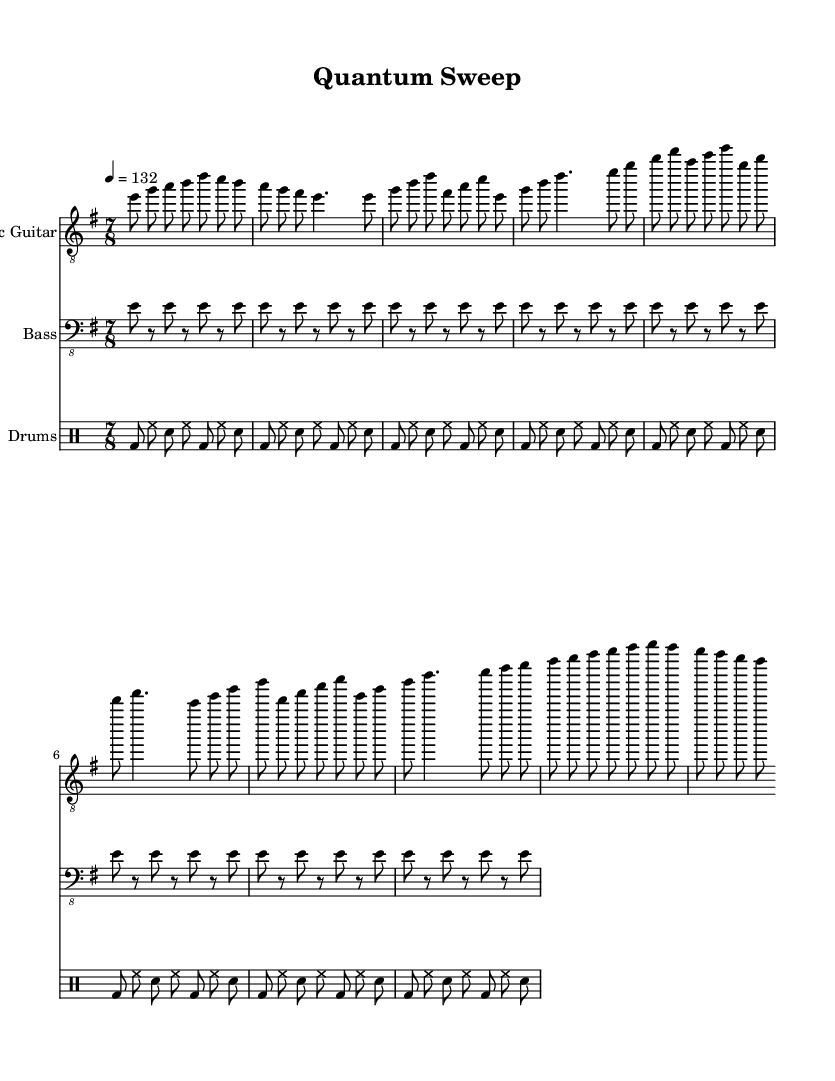What is the key signature of this music? The key signature is indicated by the presence of one sharp, which is F#. This means the piece is in E minor.
Answer: E minor What is the time signature of this music? The time signature appears at the beginning of the score, indicating that there are seven eighth notes per measure, which is expressed as 7/8.
Answer: 7/8 What is the tempo marking for this piece? The tempo marking in the score indicates a speed of quarter note = 132 beats per minute, which is represented in the score as "4 = 132."
Answer: 132 How many measures are in the electric guitar part before the solo section? By counting the number of distinct phrase groupings in the electric guitar part up to the solo section, there are a total of 12 measures.
Answer: 12 What note starts the chorus section for the electric guitar? The chorus section begins with the note E, as indicated by the first note in that section of the score.
Answer: E Which instrument has a repeated rhythm pattern with rests? The bass guitar plays a repeated rhythm pattern that includes rests, as shown in its section where it alternates between playing E and the rests.
Answer: Bass How many types of instruments are featured in this score? The score features three types of instruments: electric guitar, bass, and drums, which can be identified by their respective staffs in the score.
Answer: Three 